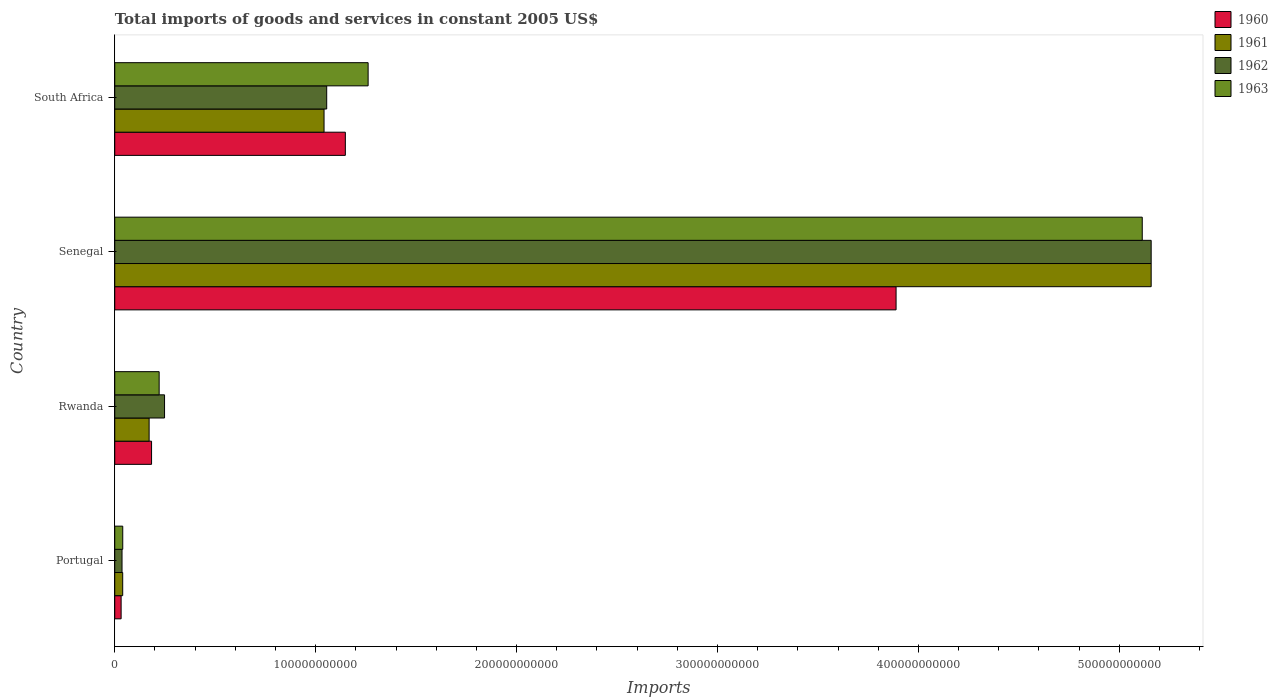Are the number of bars per tick equal to the number of legend labels?
Keep it short and to the point. Yes. Are the number of bars on each tick of the Y-axis equal?
Give a very brief answer. Yes. How many bars are there on the 1st tick from the top?
Make the answer very short. 4. How many bars are there on the 2nd tick from the bottom?
Your response must be concise. 4. What is the total imports of goods and services in 1962 in Senegal?
Offer a terse response. 5.16e+11. Across all countries, what is the maximum total imports of goods and services in 1961?
Provide a short and direct response. 5.16e+11. Across all countries, what is the minimum total imports of goods and services in 1961?
Keep it short and to the point. 3.96e+09. In which country was the total imports of goods and services in 1962 maximum?
Your response must be concise. Senegal. In which country was the total imports of goods and services in 1962 minimum?
Your answer should be compact. Portugal. What is the total total imports of goods and services in 1960 in the graph?
Offer a terse response. 5.25e+11. What is the difference between the total imports of goods and services in 1962 in Senegal and that in South Africa?
Provide a succinct answer. 4.10e+11. What is the difference between the total imports of goods and services in 1962 in Rwanda and the total imports of goods and services in 1961 in Portugal?
Provide a succinct answer. 2.08e+1. What is the average total imports of goods and services in 1961 per country?
Give a very brief answer. 1.60e+11. What is the difference between the total imports of goods and services in 1961 and total imports of goods and services in 1963 in Portugal?
Offer a terse response. -2.01e+07. What is the ratio of the total imports of goods and services in 1962 in Rwanda to that in Senegal?
Offer a terse response. 0.05. Is the total imports of goods and services in 1963 in Rwanda less than that in Senegal?
Make the answer very short. Yes. Is the difference between the total imports of goods and services in 1961 in Rwanda and Senegal greater than the difference between the total imports of goods and services in 1963 in Rwanda and Senegal?
Provide a succinct answer. No. What is the difference between the highest and the second highest total imports of goods and services in 1963?
Provide a short and direct response. 3.85e+11. What is the difference between the highest and the lowest total imports of goods and services in 1963?
Keep it short and to the point. 5.07e+11. Is it the case that in every country, the sum of the total imports of goods and services in 1961 and total imports of goods and services in 1962 is greater than the sum of total imports of goods and services in 1963 and total imports of goods and services in 1960?
Offer a very short reply. No. What does the 2nd bar from the bottom in Rwanda represents?
Give a very brief answer. 1961. Is it the case that in every country, the sum of the total imports of goods and services in 1963 and total imports of goods and services in 1960 is greater than the total imports of goods and services in 1962?
Give a very brief answer. Yes. How many bars are there?
Your answer should be compact. 16. Are all the bars in the graph horizontal?
Provide a succinct answer. Yes. How many countries are there in the graph?
Offer a terse response. 4. What is the difference between two consecutive major ticks on the X-axis?
Make the answer very short. 1.00e+11. Are the values on the major ticks of X-axis written in scientific E-notation?
Offer a very short reply. No. Does the graph contain any zero values?
Offer a terse response. No. Does the graph contain grids?
Ensure brevity in your answer.  No. Where does the legend appear in the graph?
Keep it short and to the point. Top right. How are the legend labels stacked?
Your answer should be compact. Vertical. What is the title of the graph?
Your response must be concise. Total imports of goods and services in constant 2005 US$. Does "1967" appear as one of the legend labels in the graph?
Your response must be concise. No. What is the label or title of the X-axis?
Offer a terse response. Imports. What is the Imports in 1960 in Portugal?
Offer a very short reply. 3.17e+09. What is the Imports in 1961 in Portugal?
Provide a succinct answer. 3.96e+09. What is the Imports in 1962 in Portugal?
Ensure brevity in your answer.  3.62e+09. What is the Imports of 1963 in Portugal?
Make the answer very short. 3.98e+09. What is the Imports of 1960 in Rwanda?
Provide a short and direct response. 1.83e+1. What is the Imports of 1961 in Rwanda?
Your answer should be very brief. 1.71e+1. What is the Imports in 1962 in Rwanda?
Give a very brief answer. 2.48e+1. What is the Imports of 1963 in Rwanda?
Give a very brief answer. 2.21e+1. What is the Imports in 1960 in Senegal?
Make the answer very short. 3.89e+11. What is the Imports of 1961 in Senegal?
Keep it short and to the point. 5.16e+11. What is the Imports in 1962 in Senegal?
Provide a succinct answer. 5.16e+11. What is the Imports of 1963 in Senegal?
Your answer should be compact. 5.11e+11. What is the Imports in 1960 in South Africa?
Your answer should be very brief. 1.15e+11. What is the Imports of 1961 in South Africa?
Keep it short and to the point. 1.04e+11. What is the Imports of 1962 in South Africa?
Keep it short and to the point. 1.05e+11. What is the Imports in 1963 in South Africa?
Provide a succinct answer. 1.26e+11. Across all countries, what is the maximum Imports of 1960?
Give a very brief answer. 3.89e+11. Across all countries, what is the maximum Imports of 1961?
Provide a short and direct response. 5.16e+11. Across all countries, what is the maximum Imports of 1962?
Keep it short and to the point. 5.16e+11. Across all countries, what is the maximum Imports of 1963?
Ensure brevity in your answer.  5.11e+11. Across all countries, what is the minimum Imports of 1960?
Provide a short and direct response. 3.17e+09. Across all countries, what is the minimum Imports in 1961?
Keep it short and to the point. 3.96e+09. Across all countries, what is the minimum Imports in 1962?
Your answer should be compact. 3.62e+09. Across all countries, what is the minimum Imports of 1963?
Your answer should be compact. 3.98e+09. What is the total Imports of 1960 in the graph?
Your response must be concise. 5.25e+11. What is the total Imports in 1961 in the graph?
Your answer should be compact. 6.41e+11. What is the total Imports of 1962 in the graph?
Your answer should be compact. 6.50e+11. What is the total Imports in 1963 in the graph?
Give a very brief answer. 6.64e+11. What is the difference between the Imports in 1960 in Portugal and that in Rwanda?
Make the answer very short. -1.52e+1. What is the difference between the Imports in 1961 in Portugal and that in Rwanda?
Provide a succinct answer. -1.32e+1. What is the difference between the Imports of 1962 in Portugal and that in Rwanda?
Provide a short and direct response. -2.12e+1. What is the difference between the Imports of 1963 in Portugal and that in Rwanda?
Offer a very short reply. -1.81e+1. What is the difference between the Imports in 1960 in Portugal and that in Senegal?
Your answer should be very brief. -3.86e+11. What is the difference between the Imports of 1961 in Portugal and that in Senegal?
Your answer should be compact. -5.12e+11. What is the difference between the Imports in 1962 in Portugal and that in Senegal?
Your response must be concise. -5.12e+11. What is the difference between the Imports in 1963 in Portugal and that in Senegal?
Make the answer very short. -5.07e+11. What is the difference between the Imports in 1960 in Portugal and that in South Africa?
Your response must be concise. -1.12e+11. What is the difference between the Imports of 1961 in Portugal and that in South Africa?
Give a very brief answer. -1.00e+11. What is the difference between the Imports in 1962 in Portugal and that in South Africa?
Your answer should be compact. -1.02e+11. What is the difference between the Imports of 1963 in Portugal and that in South Africa?
Ensure brevity in your answer.  -1.22e+11. What is the difference between the Imports in 1960 in Rwanda and that in Senegal?
Your answer should be very brief. -3.71e+11. What is the difference between the Imports of 1961 in Rwanda and that in Senegal?
Offer a terse response. -4.99e+11. What is the difference between the Imports in 1962 in Rwanda and that in Senegal?
Give a very brief answer. -4.91e+11. What is the difference between the Imports in 1963 in Rwanda and that in Senegal?
Provide a short and direct response. -4.89e+11. What is the difference between the Imports in 1960 in Rwanda and that in South Africa?
Provide a short and direct response. -9.65e+1. What is the difference between the Imports of 1961 in Rwanda and that in South Africa?
Your answer should be compact. -8.71e+1. What is the difference between the Imports of 1962 in Rwanda and that in South Africa?
Give a very brief answer. -8.07e+1. What is the difference between the Imports in 1963 in Rwanda and that in South Africa?
Your answer should be very brief. -1.04e+11. What is the difference between the Imports of 1960 in Senegal and that in South Africa?
Ensure brevity in your answer.  2.74e+11. What is the difference between the Imports of 1961 in Senegal and that in South Africa?
Your answer should be compact. 4.12e+11. What is the difference between the Imports in 1962 in Senegal and that in South Africa?
Provide a short and direct response. 4.10e+11. What is the difference between the Imports of 1963 in Senegal and that in South Africa?
Offer a very short reply. 3.85e+11. What is the difference between the Imports of 1960 in Portugal and the Imports of 1961 in Rwanda?
Make the answer very short. -1.39e+1. What is the difference between the Imports of 1960 in Portugal and the Imports of 1962 in Rwanda?
Offer a very short reply. -2.16e+1. What is the difference between the Imports in 1960 in Portugal and the Imports in 1963 in Rwanda?
Keep it short and to the point. -1.89e+1. What is the difference between the Imports in 1961 in Portugal and the Imports in 1962 in Rwanda?
Provide a succinct answer. -2.08e+1. What is the difference between the Imports of 1961 in Portugal and the Imports of 1963 in Rwanda?
Offer a very short reply. -1.81e+1. What is the difference between the Imports of 1962 in Portugal and the Imports of 1963 in Rwanda?
Offer a very short reply. -1.85e+1. What is the difference between the Imports of 1960 in Portugal and the Imports of 1961 in Senegal?
Give a very brief answer. -5.13e+11. What is the difference between the Imports of 1960 in Portugal and the Imports of 1962 in Senegal?
Make the answer very short. -5.13e+11. What is the difference between the Imports in 1960 in Portugal and the Imports in 1963 in Senegal?
Provide a succinct answer. -5.08e+11. What is the difference between the Imports of 1961 in Portugal and the Imports of 1962 in Senegal?
Give a very brief answer. -5.12e+11. What is the difference between the Imports in 1961 in Portugal and the Imports in 1963 in Senegal?
Your answer should be compact. -5.07e+11. What is the difference between the Imports of 1962 in Portugal and the Imports of 1963 in Senegal?
Offer a very short reply. -5.08e+11. What is the difference between the Imports in 1960 in Portugal and the Imports in 1961 in South Africa?
Make the answer very short. -1.01e+11. What is the difference between the Imports of 1960 in Portugal and the Imports of 1962 in South Africa?
Make the answer very short. -1.02e+11. What is the difference between the Imports of 1960 in Portugal and the Imports of 1963 in South Africa?
Keep it short and to the point. -1.23e+11. What is the difference between the Imports of 1961 in Portugal and the Imports of 1962 in South Africa?
Ensure brevity in your answer.  -1.02e+11. What is the difference between the Imports of 1961 in Portugal and the Imports of 1963 in South Africa?
Offer a very short reply. -1.22e+11. What is the difference between the Imports in 1962 in Portugal and the Imports in 1963 in South Africa?
Keep it short and to the point. -1.23e+11. What is the difference between the Imports of 1960 in Rwanda and the Imports of 1961 in Senegal?
Your answer should be compact. -4.98e+11. What is the difference between the Imports in 1960 in Rwanda and the Imports in 1962 in Senegal?
Keep it short and to the point. -4.98e+11. What is the difference between the Imports in 1960 in Rwanda and the Imports in 1963 in Senegal?
Offer a terse response. -4.93e+11. What is the difference between the Imports of 1961 in Rwanda and the Imports of 1962 in Senegal?
Your answer should be compact. -4.99e+11. What is the difference between the Imports of 1961 in Rwanda and the Imports of 1963 in Senegal?
Make the answer very short. -4.94e+11. What is the difference between the Imports of 1962 in Rwanda and the Imports of 1963 in Senegal?
Your answer should be compact. -4.87e+11. What is the difference between the Imports in 1960 in Rwanda and the Imports in 1961 in South Africa?
Your answer should be very brief. -8.59e+1. What is the difference between the Imports of 1960 in Rwanda and the Imports of 1962 in South Africa?
Offer a terse response. -8.72e+1. What is the difference between the Imports in 1960 in Rwanda and the Imports in 1963 in South Africa?
Provide a short and direct response. -1.08e+11. What is the difference between the Imports in 1961 in Rwanda and the Imports in 1962 in South Africa?
Ensure brevity in your answer.  -8.84e+1. What is the difference between the Imports in 1961 in Rwanda and the Imports in 1963 in South Africa?
Make the answer very short. -1.09e+11. What is the difference between the Imports of 1962 in Rwanda and the Imports of 1963 in South Africa?
Offer a terse response. -1.01e+11. What is the difference between the Imports of 1960 in Senegal and the Imports of 1961 in South Africa?
Offer a very short reply. 2.85e+11. What is the difference between the Imports in 1960 in Senegal and the Imports in 1962 in South Africa?
Offer a very short reply. 2.83e+11. What is the difference between the Imports in 1960 in Senegal and the Imports in 1963 in South Africa?
Provide a succinct answer. 2.63e+11. What is the difference between the Imports in 1961 in Senegal and the Imports in 1962 in South Africa?
Keep it short and to the point. 4.10e+11. What is the difference between the Imports in 1961 in Senegal and the Imports in 1963 in South Africa?
Your answer should be compact. 3.90e+11. What is the difference between the Imports of 1962 in Senegal and the Imports of 1963 in South Africa?
Provide a succinct answer. 3.90e+11. What is the average Imports in 1960 per country?
Keep it short and to the point. 1.31e+11. What is the average Imports of 1961 per country?
Ensure brevity in your answer.  1.60e+11. What is the average Imports in 1962 per country?
Your response must be concise. 1.62e+11. What is the average Imports of 1963 per country?
Your response must be concise. 1.66e+11. What is the difference between the Imports in 1960 and Imports in 1961 in Portugal?
Provide a short and direct response. -7.89e+08. What is the difference between the Imports of 1960 and Imports of 1962 in Portugal?
Your response must be concise. -4.52e+08. What is the difference between the Imports of 1960 and Imports of 1963 in Portugal?
Give a very brief answer. -8.09e+08. What is the difference between the Imports of 1961 and Imports of 1962 in Portugal?
Keep it short and to the point. 3.37e+08. What is the difference between the Imports of 1961 and Imports of 1963 in Portugal?
Your answer should be very brief. -2.01e+07. What is the difference between the Imports of 1962 and Imports of 1963 in Portugal?
Ensure brevity in your answer.  -3.57e+08. What is the difference between the Imports in 1960 and Imports in 1961 in Rwanda?
Make the answer very short. 1.22e+09. What is the difference between the Imports of 1960 and Imports of 1962 in Rwanda?
Keep it short and to the point. -6.46e+09. What is the difference between the Imports of 1960 and Imports of 1963 in Rwanda?
Make the answer very short. -3.77e+09. What is the difference between the Imports in 1961 and Imports in 1962 in Rwanda?
Your answer should be compact. -7.68e+09. What is the difference between the Imports in 1961 and Imports in 1963 in Rwanda?
Make the answer very short. -4.99e+09. What is the difference between the Imports in 1962 and Imports in 1963 in Rwanda?
Offer a very short reply. 2.68e+09. What is the difference between the Imports in 1960 and Imports in 1961 in Senegal?
Your response must be concise. -1.27e+11. What is the difference between the Imports in 1960 and Imports in 1962 in Senegal?
Offer a terse response. -1.27e+11. What is the difference between the Imports in 1960 and Imports in 1963 in Senegal?
Offer a very short reply. -1.23e+11. What is the difference between the Imports in 1961 and Imports in 1962 in Senegal?
Your answer should be compact. 0. What is the difference between the Imports in 1961 and Imports in 1963 in Senegal?
Provide a short and direct response. 4.44e+09. What is the difference between the Imports in 1962 and Imports in 1963 in Senegal?
Make the answer very short. 4.44e+09. What is the difference between the Imports of 1960 and Imports of 1961 in South Africa?
Ensure brevity in your answer.  1.06e+1. What is the difference between the Imports of 1960 and Imports of 1962 in South Africa?
Keep it short and to the point. 9.28e+09. What is the difference between the Imports in 1960 and Imports in 1963 in South Africa?
Your answer should be compact. -1.13e+1. What is the difference between the Imports of 1961 and Imports of 1962 in South Africa?
Make the answer very short. -1.32e+09. What is the difference between the Imports in 1961 and Imports in 1963 in South Africa?
Your answer should be compact. -2.19e+1. What is the difference between the Imports of 1962 and Imports of 1963 in South Africa?
Give a very brief answer. -2.06e+1. What is the ratio of the Imports of 1960 in Portugal to that in Rwanda?
Keep it short and to the point. 0.17. What is the ratio of the Imports of 1961 in Portugal to that in Rwanda?
Make the answer very short. 0.23. What is the ratio of the Imports of 1962 in Portugal to that in Rwanda?
Your answer should be very brief. 0.15. What is the ratio of the Imports of 1963 in Portugal to that in Rwanda?
Keep it short and to the point. 0.18. What is the ratio of the Imports in 1960 in Portugal to that in Senegal?
Ensure brevity in your answer.  0.01. What is the ratio of the Imports in 1961 in Portugal to that in Senegal?
Provide a succinct answer. 0.01. What is the ratio of the Imports of 1962 in Portugal to that in Senegal?
Offer a terse response. 0.01. What is the ratio of the Imports in 1963 in Portugal to that in Senegal?
Provide a short and direct response. 0.01. What is the ratio of the Imports of 1960 in Portugal to that in South Africa?
Provide a succinct answer. 0.03. What is the ratio of the Imports in 1961 in Portugal to that in South Africa?
Provide a succinct answer. 0.04. What is the ratio of the Imports in 1962 in Portugal to that in South Africa?
Provide a short and direct response. 0.03. What is the ratio of the Imports of 1963 in Portugal to that in South Africa?
Ensure brevity in your answer.  0.03. What is the ratio of the Imports in 1960 in Rwanda to that in Senegal?
Your response must be concise. 0.05. What is the ratio of the Imports of 1961 in Rwanda to that in Senegal?
Provide a short and direct response. 0.03. What is the ratio of the Imports in 1962 in Rwanda to that in Senegal?
Your answer should be compact. 0.05. What is the ratio of the Imports in 1963 in Rwanda to that in Senegal?
Your response must be concise. 0.04. What is the ratio of the Imports of 1960 in Rwanda to that in South Africa?
Keep it short and to the point. 0.16. What is the ratio of the Imports of 1961 in Rwanda to that in South Africa?
Offer a terse response. 0.16. What is the ratio of the Imports in 1962 in Rwanda to that in South Africa?
Provide a short and direct response. 0.23. What is the ratio of the Imports of 1963 in Rwanda to that in South Africa?
Keep it short and to the point. 0.18. What is the ratio of the Imports of 1960 in Senegal to that in South Africa?
Keep it short and to the point. 3.39. What is the ratio of the Imports in 1961 in Senegal to that in South Africa?
Your response must be concise. 4.95. What is the ratio of the Imports in 1962 in Senegal to that in South Africa?
Your answer should be very brief. 4.89. What is the ratio of the Imports in 1963 in Senegal to that in South Africa?
Offer a terse response. 4.06. What is the difference between the highest and the second highest Imports of 1960?
Provide a short and direct response. 2.74e+11. What is the difference between the highest and the second highest Imports of 1961?
Your answer should be very brief. 4.12e+11. What is the difference between the highest and the second highest Imports of 1962?
Keep it short and to the point. 4.10e+11. What is the difference between the highest and the second highest Imports in 1963?
Make the answer very short. 3.85e+11. What is the difference between the highest and the lowest Imports of 1960?
Provide a succinct answer. 3.86e+11. What is the difference between the highest and the lowest Imports of 1961?
Offer a very short reply. 5.12e+11. What is the difference between the highest and the lowest Imports of 1962?
Give a very brief answer. 5.12e+11. What is the difference between the highest and the lowest Imports of 1963?
Keep it short and to the point. 5.07e+11. 